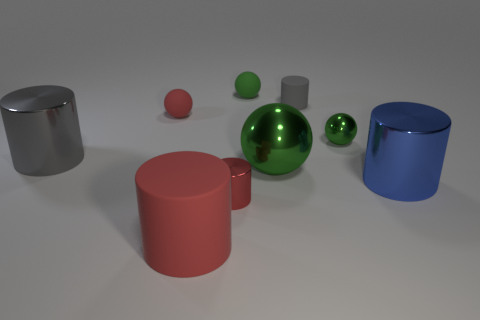There is a large rubber object; are there any large blue metallic cylinders in front of it?
Keep it short and to the point. No. There is a large rubber thing; is it the same color as the matte sphere to the left of the large red matte cylinder?
Your answer should be very brief. Yes. What color is the thing that is in front of the tiny cylinder that is in front of the gray cylinder that is to the left of the green matte thing?
Offer a terse response. Red. Is there a large blue thing of the same shape as the gray metallic object?
Offer a terse response. Yes. What is the color of the metallic cylinder that is the same size as the blue object?
Provide a short and direct response. Gray. What is the material of the tiny cylinder that is in front of the blue metallic cylinder?
Provide a succinct answer. Metal. Is the shape of the red matte thing in front of the small red rubber ball the same as the tiny red object in front of the tiny metallic ball?
Give a very brief answer. Yes. Is the number of small gray matte objects that are to the left of the large green metal sphere the same as the number of red objects?
Ensure brevity in your answer.  No. How many big green balls are made of the same material as the big green thing?
Offer a very short reply. 0. What is the color of the tiny ball that is made of the same material as the large gray cylinder?
Offer a terse response. Green. 